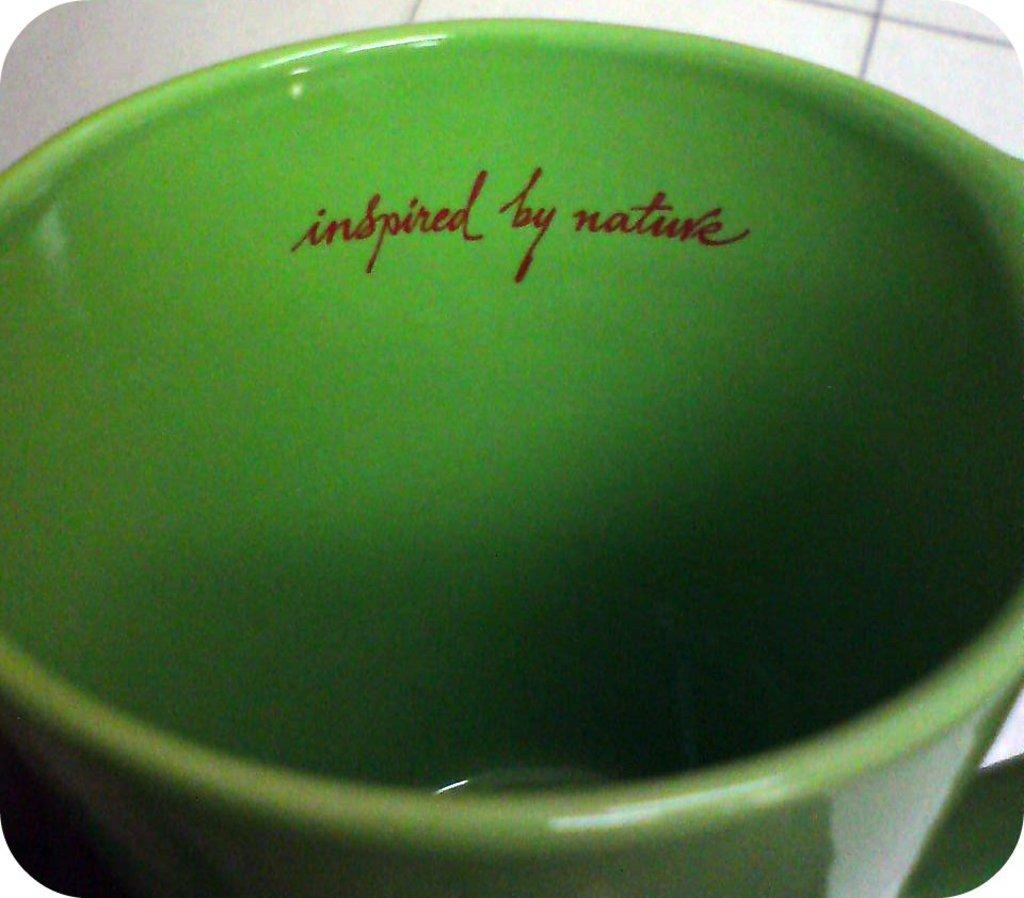What object is present in the image that can hold items? There is a container in the image. What color is the container? The container is green in color. Is there any text visible on the container? Yes, there is text visible on the container. How many trees are visible on the container in the image? There are no trees visible on the container in the image. Can you order the container directly from the image? The image does not provide a way to order the container directly. 